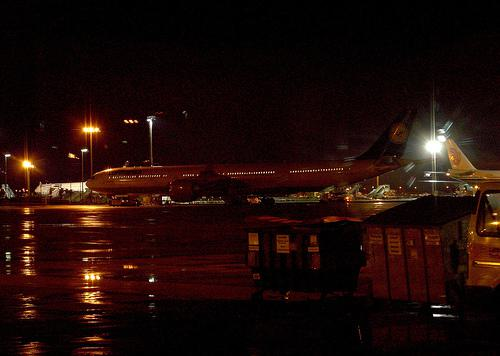How many aeroplanes would there be in the image if two aeroplanes were deleted from the scence? If two aeroplanes were removed from the initial count depicted in the image, which shows three airplanes at an airport, there would be one airplane remaining. 